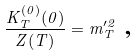<formula> <loc_0><loc_0><loc_500><loc_500>\frac { K ^ { ( 0 ) } _ { T } ( 0 ) } { Z ( T ) } = m ^ { \prime 2 } _ { T } \text { ,}</formula> 